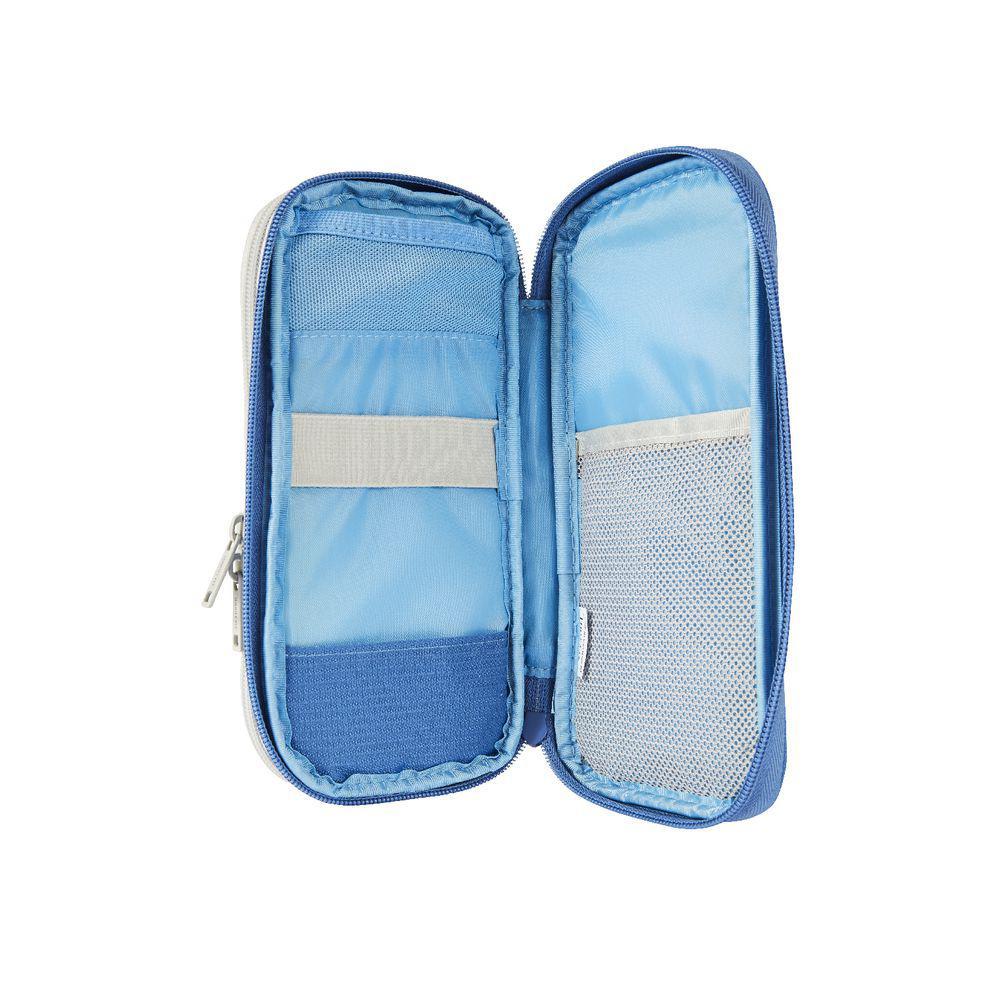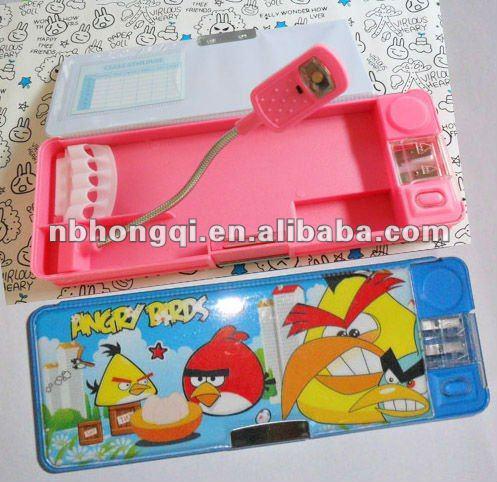The first image is the image on the left, the second image is the image on the right. Examine the images to the left and right. Is the description "The image on the left shows a single pencil case that is closed." accurate? Answer yes or no. No. The first image is the image on the left, the second image is the image on the right. Examine the images to the left and right. Is the description "There are two open pencil cases." accurate? Answer yes or no. Yes. 